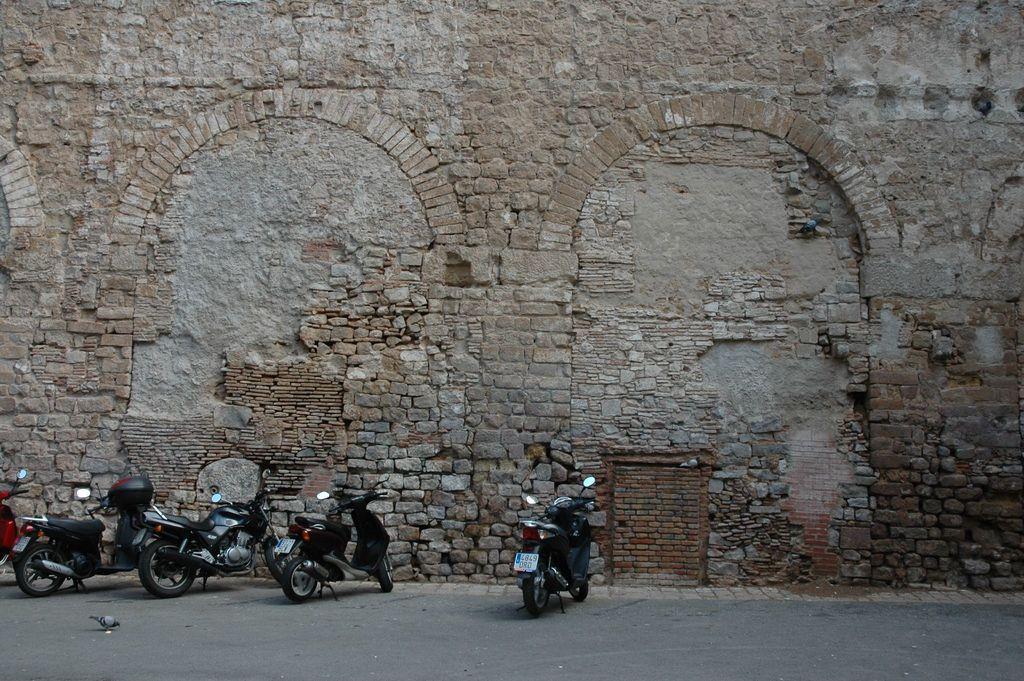How would you summarize this image in a sentence or two? In this picture I can see there are few two wheeler at left side. In the backdrop there is a brick wall. It looks like the wall is very old. 